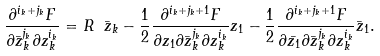Convert formula to latex. <formula><loc_0><loc_0><loc_500><loc_500>\frac { \partial ^ { i _ { k } + j _ { k } } F } { \partial \bar { z } _ { k } ^ { j _ { k } } \partial z _ { k } ^ { i _ { k } } } = R \ \bar { z } _ { k } - \frac { 1 } { 2 } \frac { \partial ^ { i _ { k } + j _ { k } + 1 } F } { \partial z _ { 1 } \partial \bar { z } _ { k } ^ { j _ { k } } \partial z _ { k } ^ { i _ { k } } } z _ { 1 } - \frac { 1 } { 2 } \frac { \partial ^ { i _ { k } + j _ { k } + 1 } F } { \partial \bar { z _ { 1 } } \partial \bar { z } _ { k } ^ { j _ { k } } \partial z _ { k } ^ { i _ { k } } } \bar { z } _ { 1 } .</formula> 